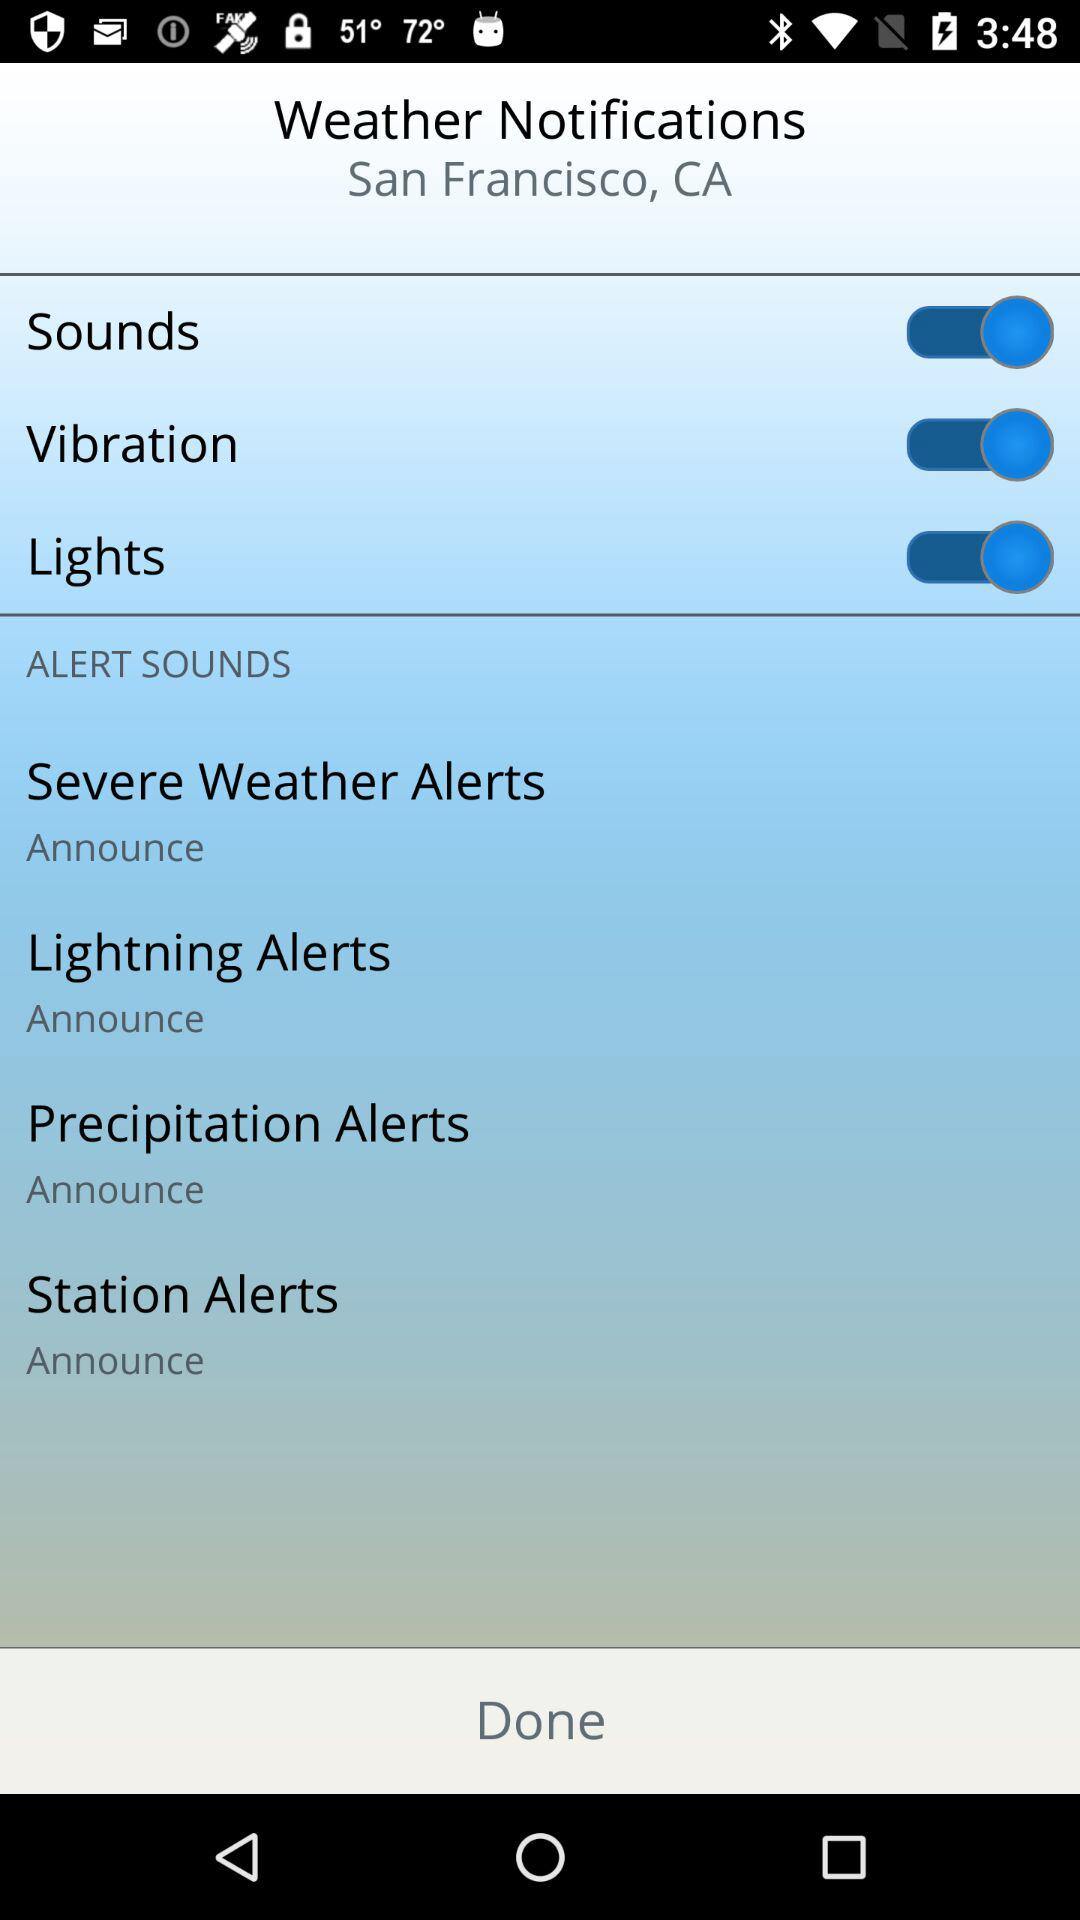What are the different options that are enabled? The different enabled options are "Sounds", "Vibration" and "Lights". 